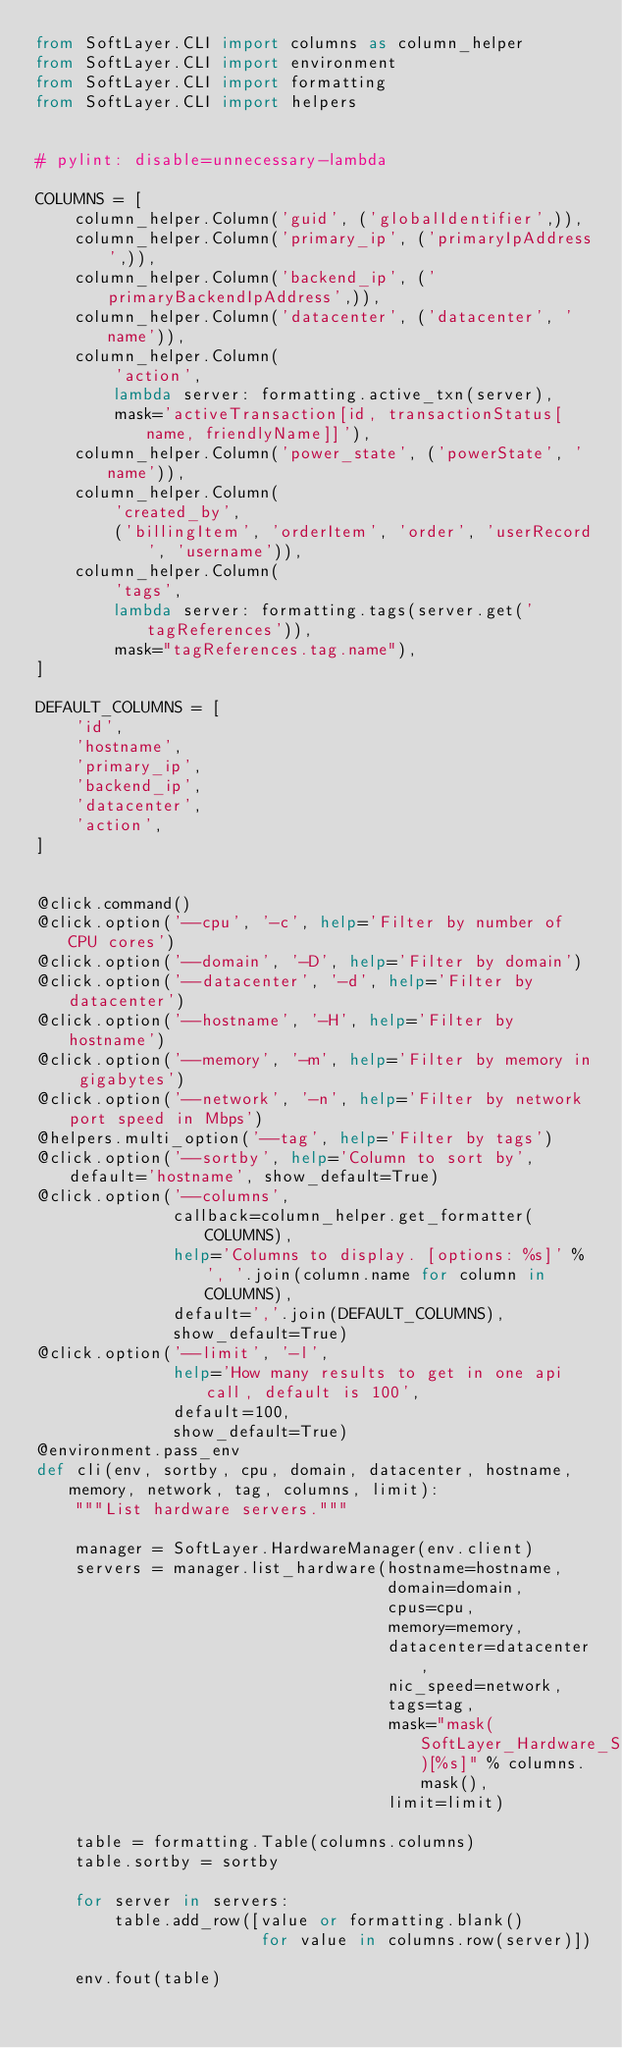<code> <loc_0><loc_0><loc_500><loc_500><_Python_>from SoftLayer.CLI import columns as column_helper
from SoftLayer.CLI import environment
from SoftLayer.CLI import formatting
from SoftLayer.CLI import helpers


# pylint: disable=unnecessary-lambda

COLUMNS = [
    column_helper.Column('guid', ('globalIdentifier',)),
    column_helper.Column('primary_ip', ('primaryIpAddress',)),
    column_helper.Column('backend_ip', ('primaryBackendIpAddress',)),
    column_helper.Column('datacenter', ('datacenter', 'name')),
    column_helper.Column(
        'action',
        lambda server: formatting.active_txn(server),
        mask='activeTransaction[id, transactionStatus[name, friendlyName]]'),
    column_helper.Column('power_state', ('powerState', 'name')),
    column_helper.Column(
        'created_by',
        ('billingItem', 'orderItem', 'order', 'userRecord', 'username')),
    column_helper.Column(
        'tags',
        lambda server: formatting.tags(server.get('tagReferences')),
        mask="tagReferences.tag.name"),
]

DEFAULT_COLUMNS = [
    'id',
    'hostname',
    'primary_ip',
    'backend_ip',
    'datacenter',
    'action',
]


@click.command()
@click.option('--cpu', '-c', help='Filter by number of CPU cores')
@click.option('--domain', '-D', help='Filter by domain')
@click.option('--datacenter', '-d', help='Filter by datacenter')
@click.option('--hostname', '-H', help='Filter by hostname')
@click.option('--memory', '-m', help='Filter by memory in gigabytes')
@click.option('--network', '-n', help='Filter by network port speed in Mbps')
@helpers.multi_option('--tag', help='Filter by tags')
@click.option('--sortby', help='Column to sort by', default='hostname', show_default=True)
@click.option('--columns',
              callback=column_helper.get_formatter(COLUMNS),
              help='Columns to display. [options: %s]' % ', '.join(column.name for column in COLUMNS),
              default=','.join(DEFAULT_COLUMNS),
              show_default=True)
@click.option('--limit', '-l',
              help='How many results to get in one api call, default is 100',
              default=100,
              show_default=True)
@environment.pass_env
def cli(env, sortby, cpu, domain, datacenter, hostname, memory, network, tag, columns, limit):
    """List hardware servers."""

    manager = SoftLayer.HardwareManager(env.client)
    servers = manager.list_hardware(hostname=hostname,
                                    domain=domain,
                                    cpus=cpu,
                                    memory=memory,
                                    datacenter=datacenter,
                                    nic_speed=network,
                                    tags=tag,
                                    mask="mask(SoftLayer_Hardware_Server)[%s]" % columns.mask(),
                                    limit=limit)

    table = formatting.Table(columns.columns)
    table.sortby = sortby

    for server in servers:
        table.add_row([value or formatting.blank()
                       for value in columns.row(server)])

    env.fout(table)
</code> 